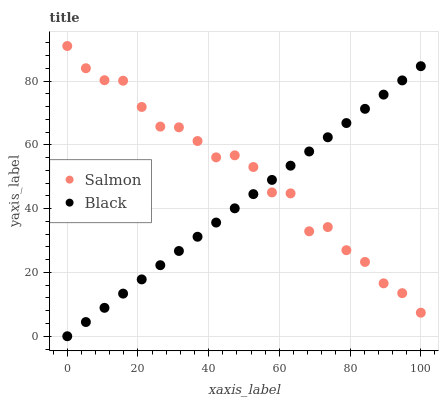Does Black have the minimum area under the curve?
Answer yes or no. Yes. Does Salmon have the maximum area under the curve?
Answer yes or no. Yes. Does Salmon have the minimum area under the curve?
Answer yes or no. No. Is Black the smoothest?
Answer yes or no. Yes. Is Salmon the roughest?
Answer yes or no. Yes. Is Salmon the smoothest?
Answer yes or no. No. Does Black have the lowest value?
Answer yes or no. Yes. Does Salmon have the lowest value?
Answer yes or no. No. Does Salmon have the highest value?
Answer yes or no. Yes. Does Black intersect Salmon?
Answer yes or no. Yes. Is Black less than Salmon?
Answer yes or no. No. Is Black greater than Salmon?
Answer yes or no. No. 